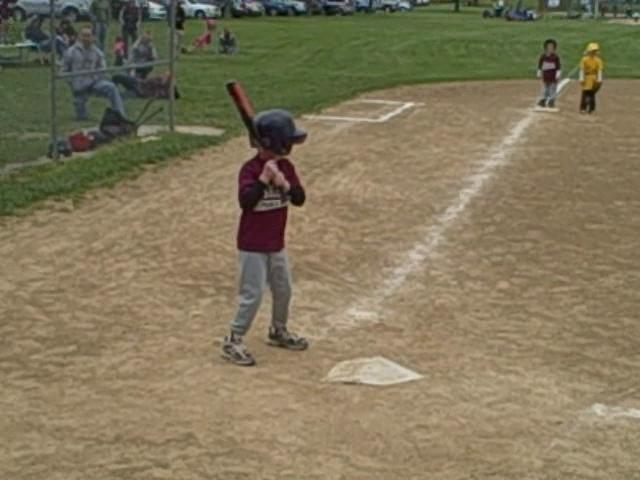What position does the player wearing yellow play?
Select the accurate response from the four choices given to answer the question.
Options: Shortstop, third base, pitcher, catcher. Third base. 